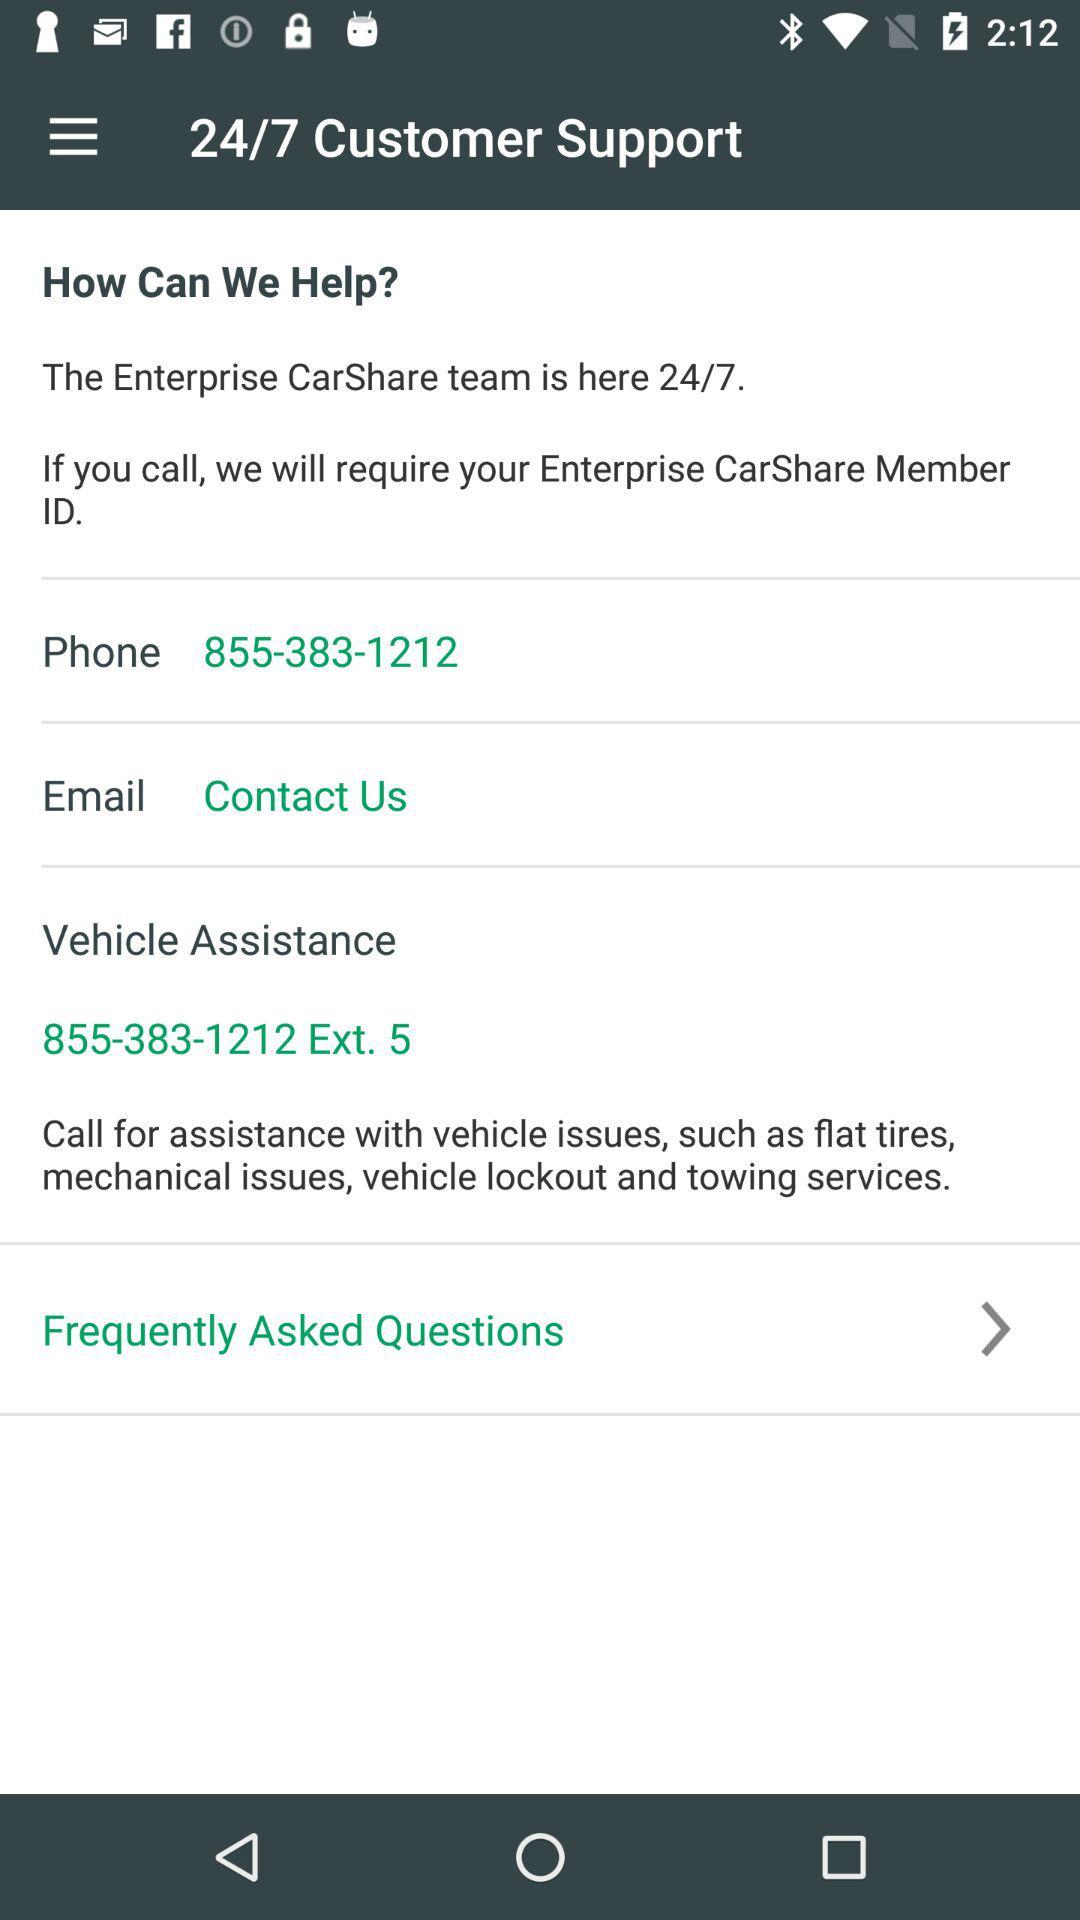How many options are there for contacting customer support?
Answer the question using a single word or phrase. 3 